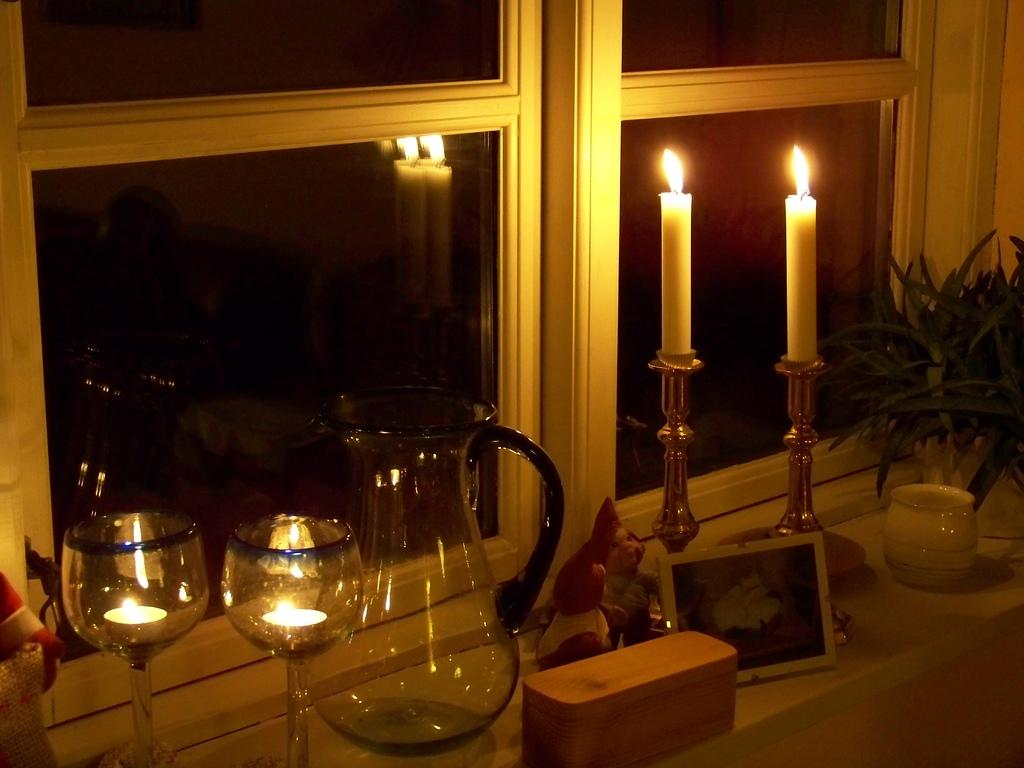What objects in the image are used for lighting? There are candles with stands in the image. What object in the image is used for displaying a photo? There is a photo frame in the image. What type of items in the image are meant for children's play? There are toys in the image. What container in the image is used for holding a liquid? There is a glass jug in the image. What objects in the image are used for drinking? There are glasses in the image. What type of living organisms are present in the image? There are plants in the image. What architectural feature in the image provides access to another area? There is a glass door in the image. What type of ray is visible in the image? There is no ray present in the image. Who is the owner of the toys in the image? The image does not provide information about the ownership of the toys. 